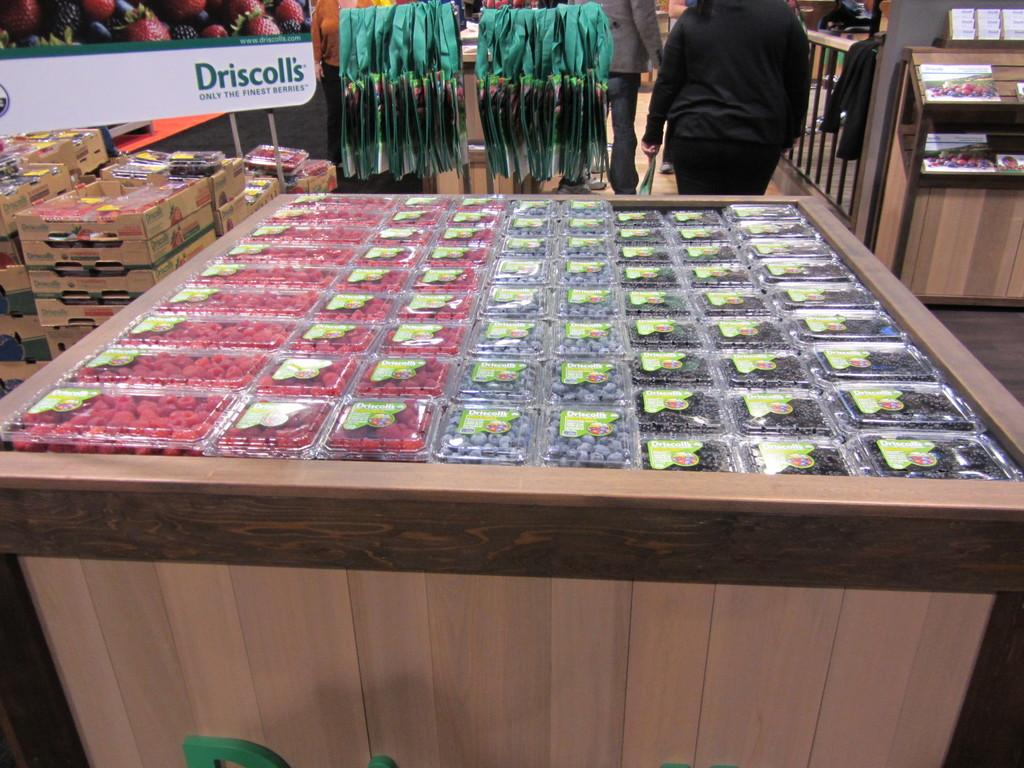<image>
Offer a succinct explanation of the picture presented. A table of packaged berries in front of a sign for Driscolli's fine berries. 